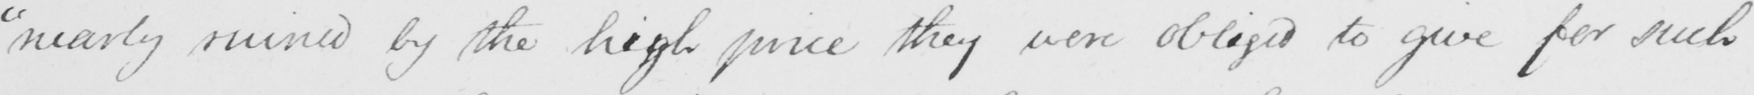What is written in this line of handwriting? " nearly ruined by the high price they were obliged to give for such 